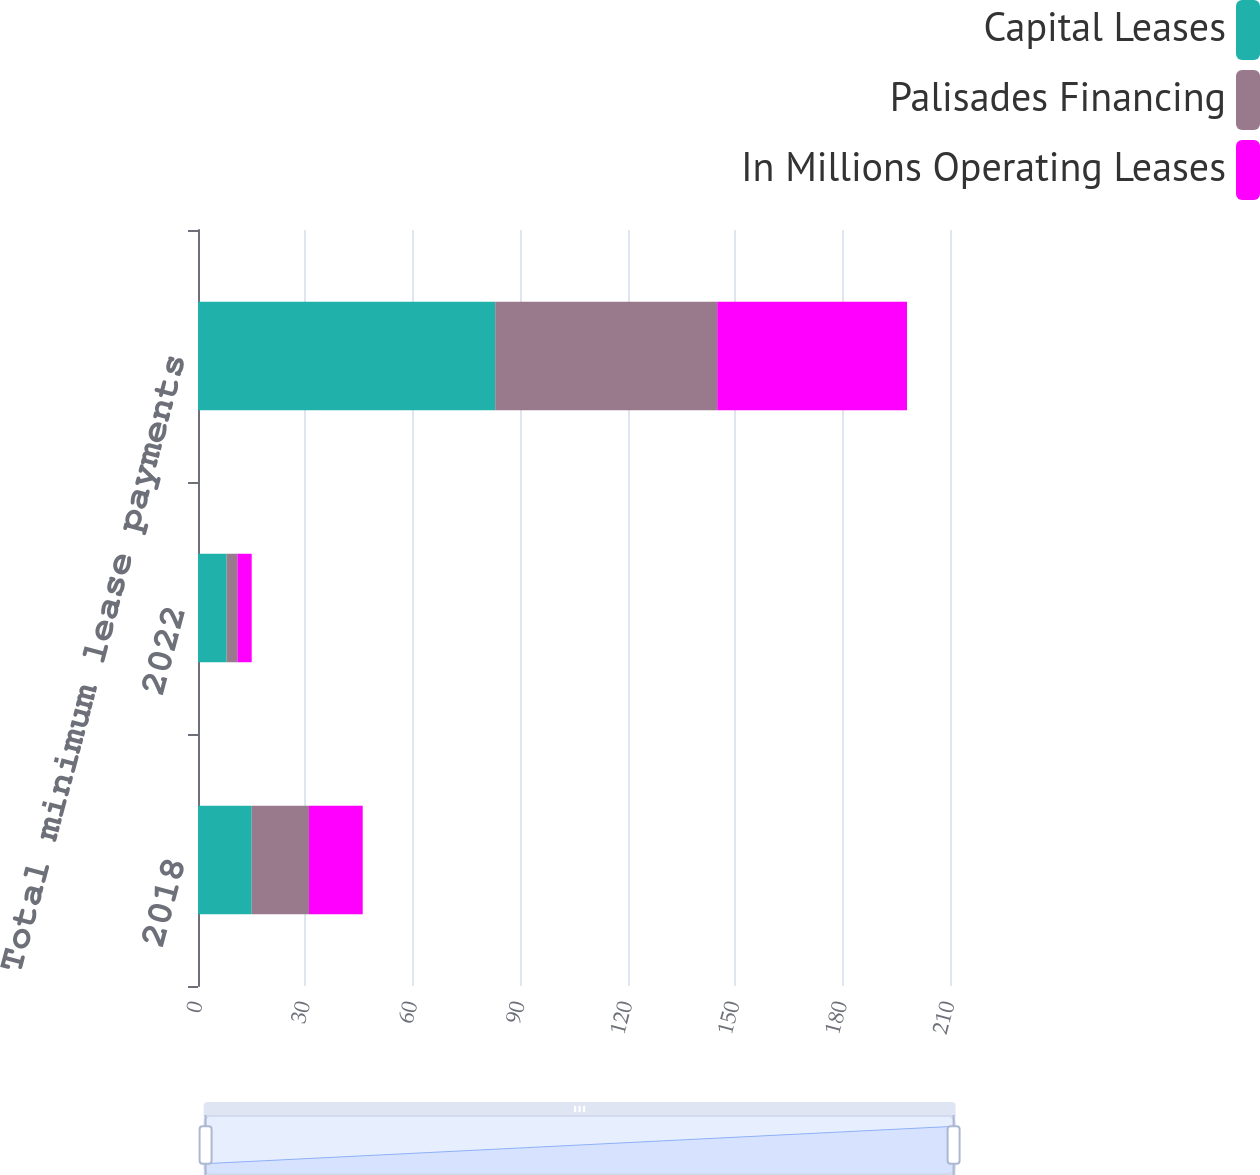Convert chart. <chart><loc_0><loc_0><loc_500><loc_500><stacked_bar_chart><ecel><fcel>2018<fcel>2022<fcel>Total minimum lease payments<nl><fcel>Capital Leases<fcel>15<fcel>8<fcel>83<nl><fcel>Palisades Financing<fcel>16<fcel>3<fcel>62<nl><fcel>In Millions Operating Leases<fcel>15<fcel>4<fcel>53<nl></chart> 